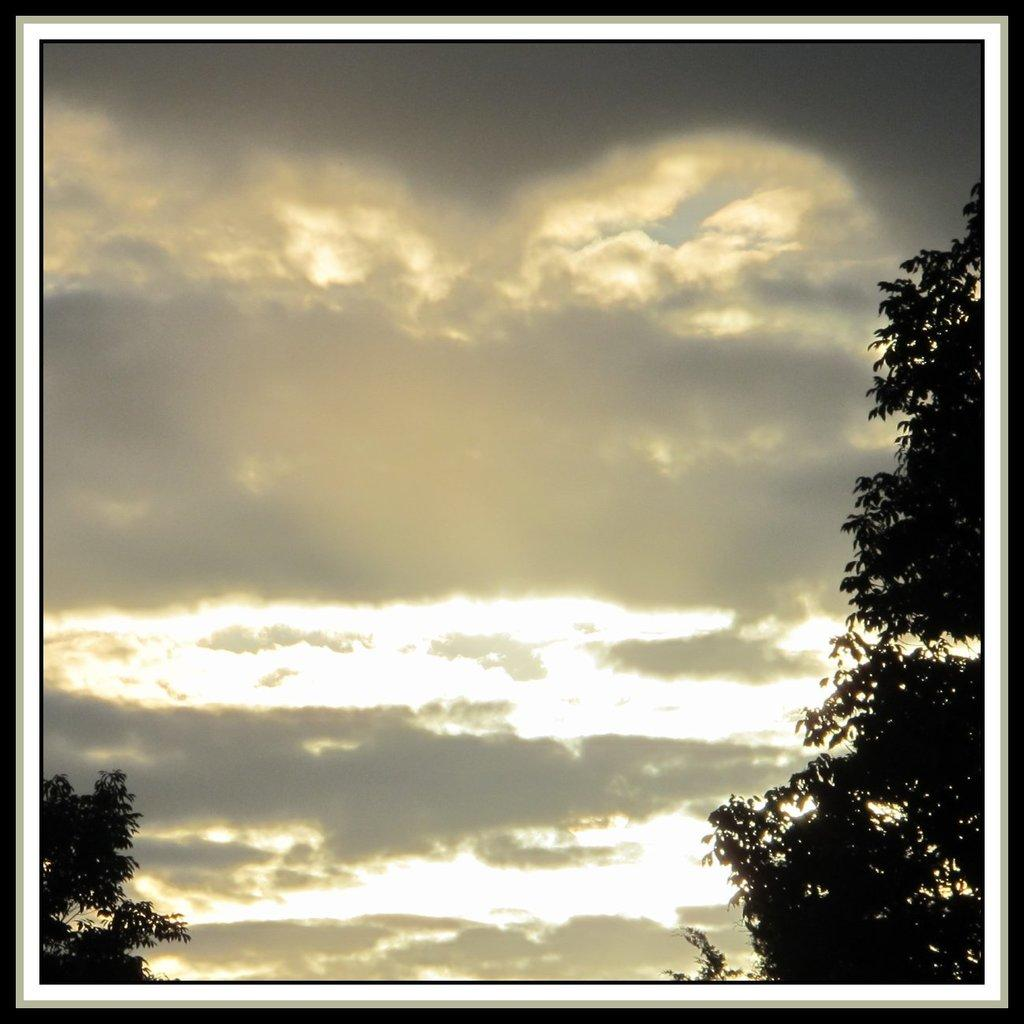What type of vegetation can be seen in the image? There are trees in the image. What part of the natural environment is visible in the image? The sky is visible in the image. Can you describe the trees in the image? The facts provided do not give specific details about the trees, so we cannot describe them further. Reasoning: Let' Let's think step by step in order to produce the conversation. We start by identifying the main subjects in the image, which are the trees and the sky. Then, we formulate questions that focus on the type of vegetation and the visible part of the natural environment. We avoid asking for specific details about the trees since the facts provided do not give enough information. Absurd Question/Answer: What type of yarn is being used by the giants in the image? There are no giants or yarn present in the image. 